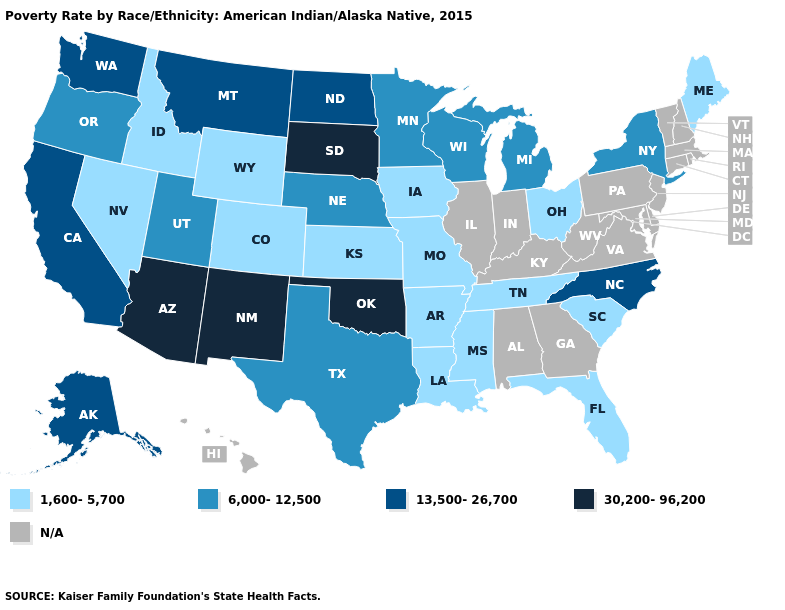Does the map have missing data?
Short answer required. Yes. What is the highest value in states that border California?
Be succinct. 30,200-96,200. How many symbols are there in the legend?
Short answer required. 5. How many symbols are there in the legend?
Answer briefly. 5. What is the value of California?
Give a very brief answer. 13,500-26,700. What is the value of Kansas?
Give a very brief answer. 1,600-5,700. What is the value of Delaware?
Be succinct. N/A. What is the value of Oklahoma?
Quick response, please. 30,200-96,200. Which states have the highest value in the USA?
Keep it brief. Arizona, New Mexico, Oklahoma, South Dakota. Does Maine have the lowest value in the USA?
Short answer required. Yes. Among the states that border Alabama , which have the lowest value?
Short answer required. Florida, Mississippi, Tennessee. What is the value of Wisconsin?
Keep it brief. 6,000-12,500. What is the value of Mississippi?
Keep it brief. 1,600-5,700. 